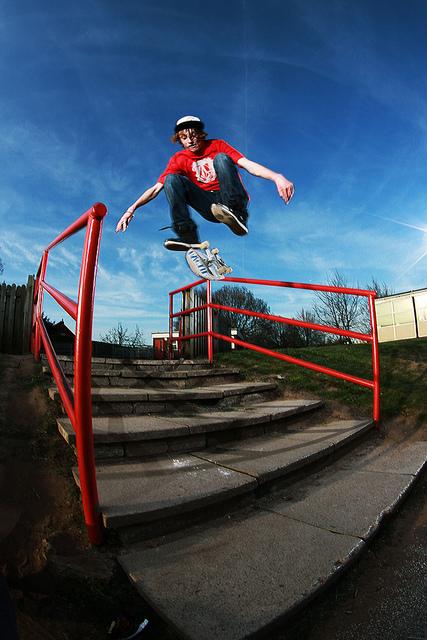What color is his shirt?
Keep it brief. Red. Is this his first day doing this sport?
Give a very brief answer. No. How many steps are in the picture?
Short answer required. 6. 